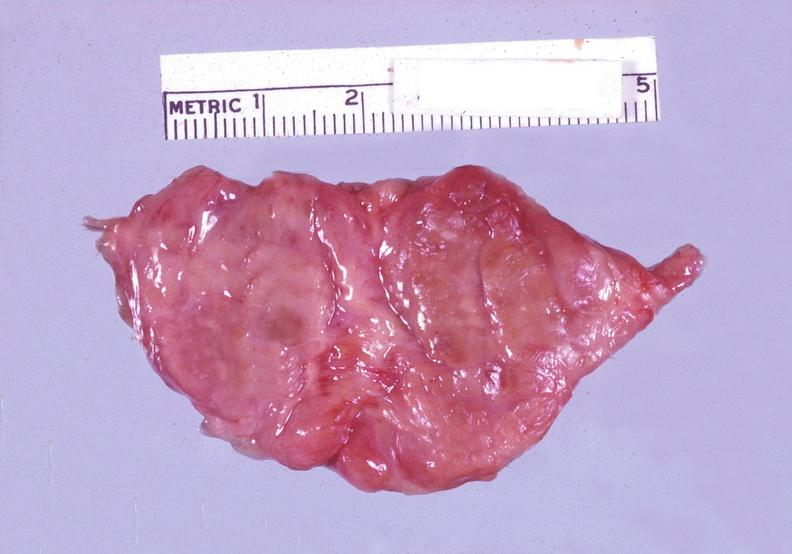where does this belong to?
Answer the question using a single word or phrase. Endocrine system 